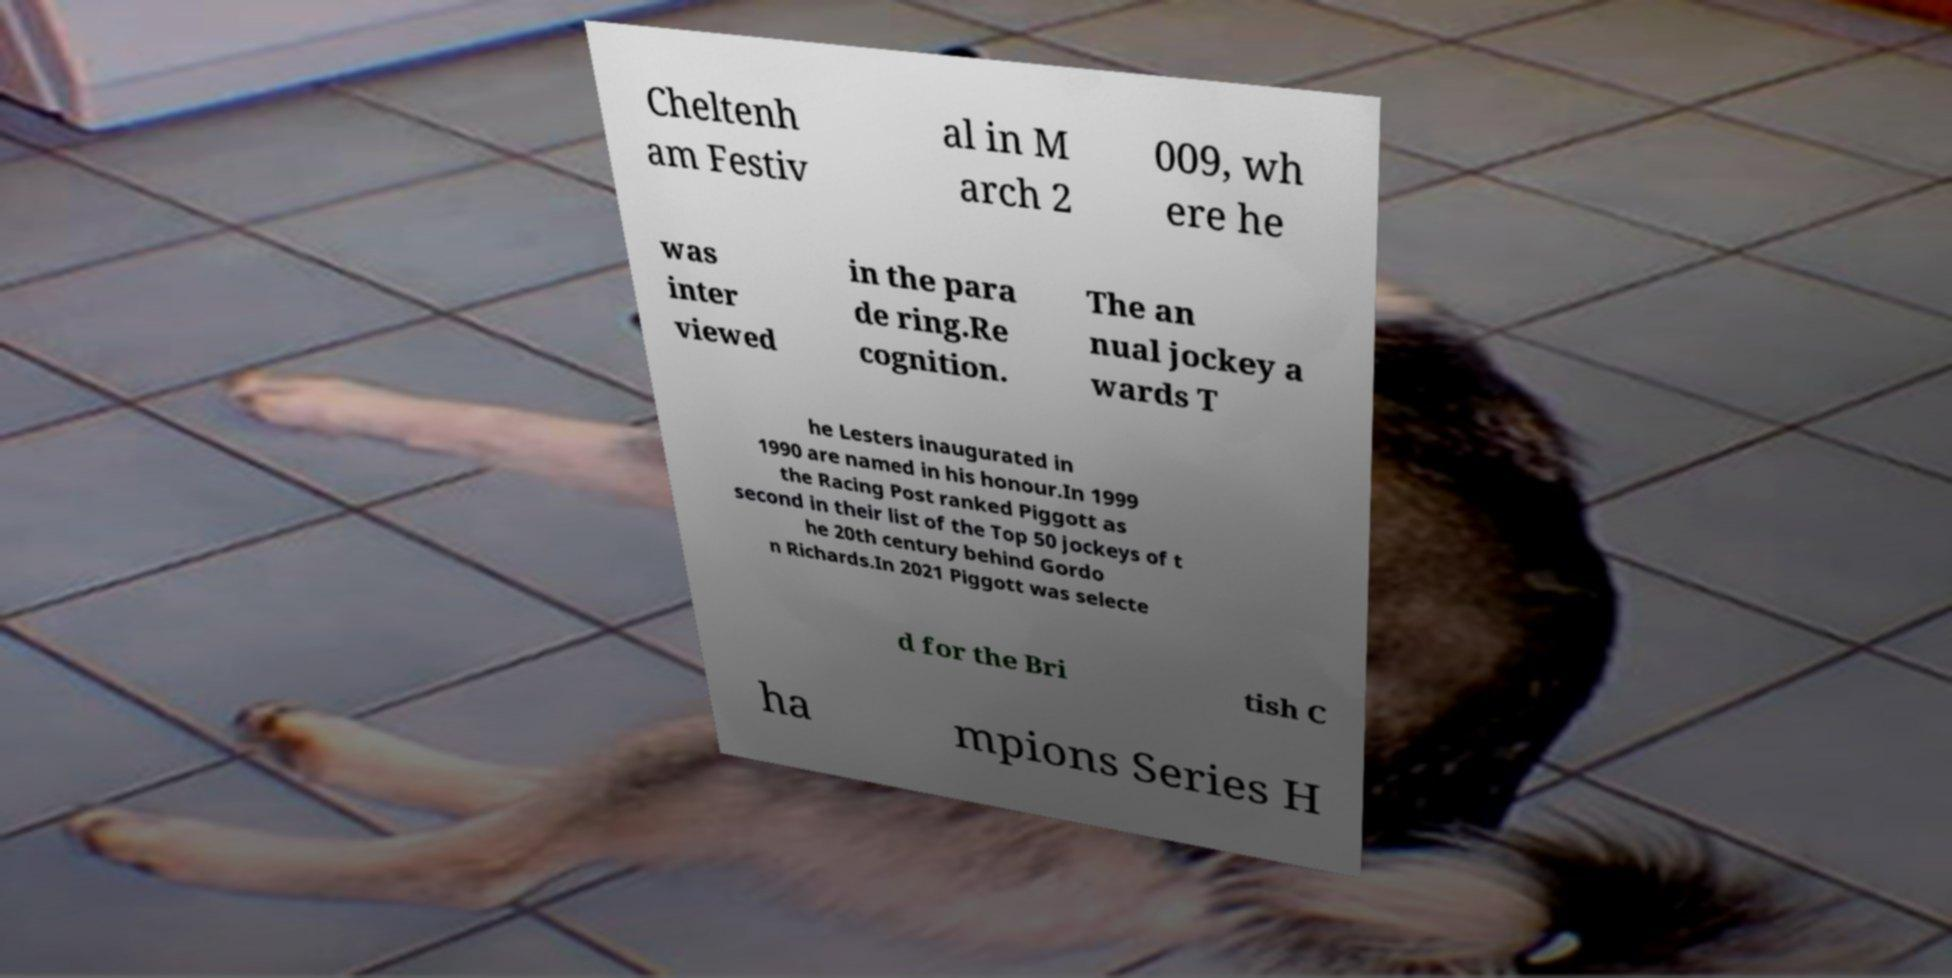Could you assist in decoding the text presented in this image and type it out clearly? Cheltenh am Festiv al in M arch 2 009, wh ere he was inter viewed in the para de ring.Re cognition. The an nual jockey a wards T he Lesters inaugurated in 1990 are named in his honour.In 1999 the Racing Post ranked Piggott as second in their list of the Top 50 jockeys of t he 20th century behind Gordo n Richards.In 2021 Piggott was selecte d for the Bri tish C ha mpions Series H 